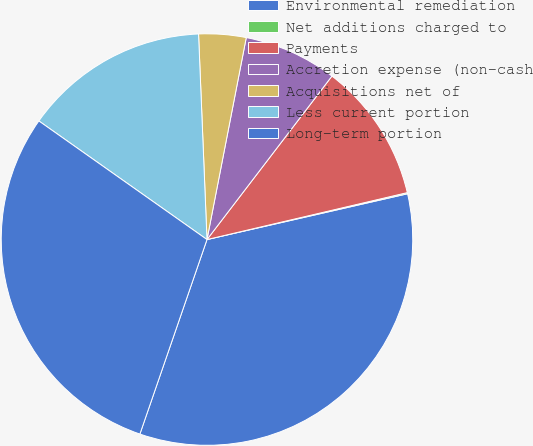Convert chart to OTSL. <chart><loc_0><loc_0><loc_500><loc_500><pie_chart><fcel>Environmental remediation<fcel>Net additions charged to<fcel>Payments<fcel>Accretion expense (non-cash<fcel>Acquisitions net of<fcel>Less current portion<fcel>Long-term portion<nl><fcel>33.86%<fcel>0.09%<fcel>10.95%<fcel>7.33%<fcel>3.71%<fcel>14.57%<fcel>29.49%<nl></chart> 